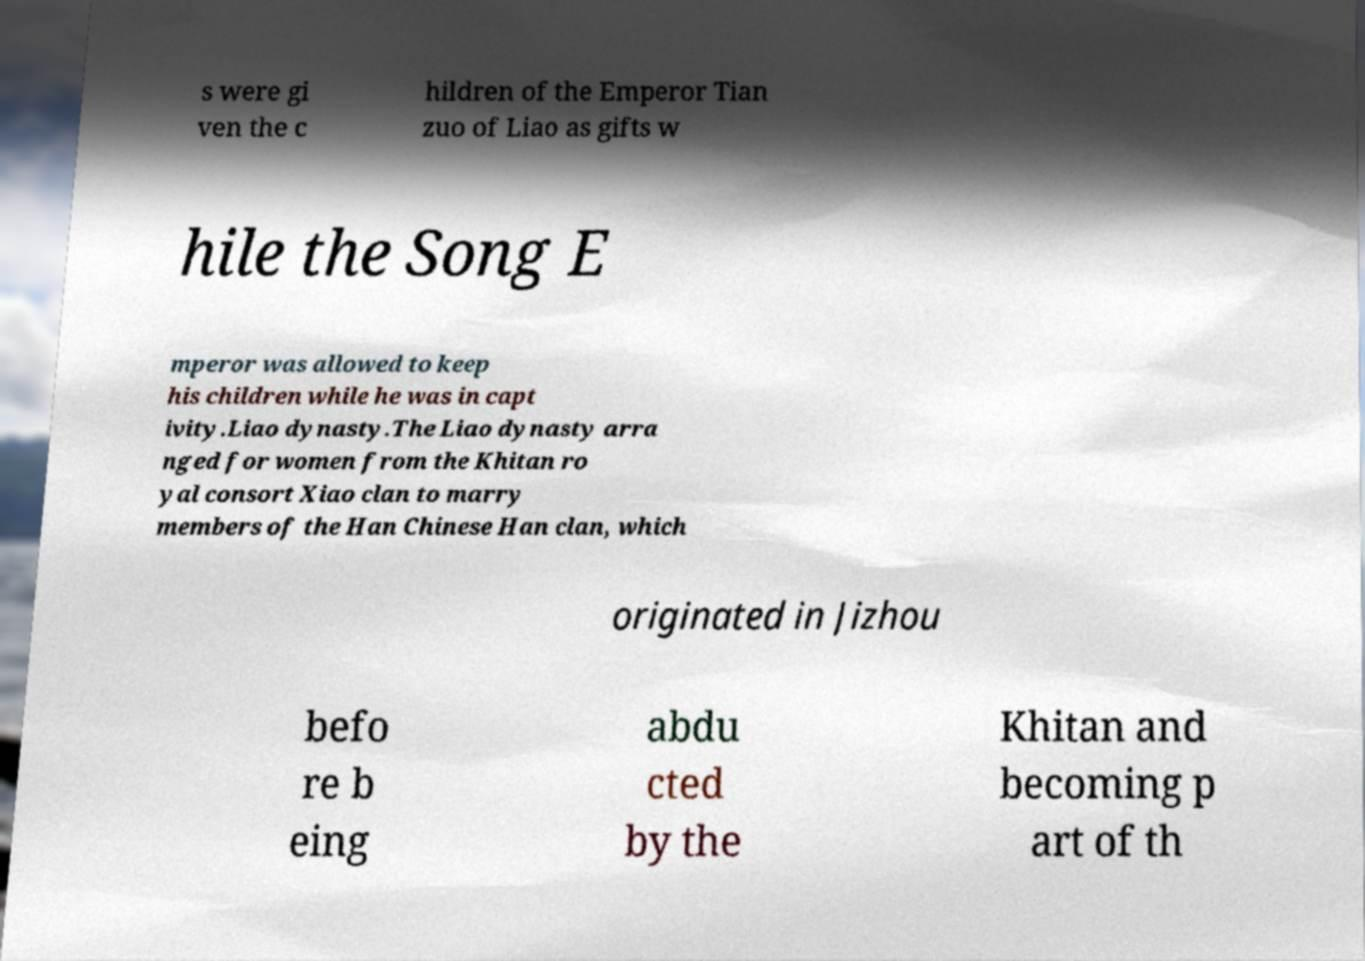Could you extract and type out the text from this image? s were gi ven the c hildren of the Emperor Tian zuo of Liao as gifts w hile the Song E mperor was allowed to keep his children while he was in capt ivity.Liao dynasty.The Liao dynasty arra nged for women from the Khitan ro yal consort Xiao clan to marry members of the Han Chinese Han clan, which originated in Jizhou befo re b eing abdu cted by the Khitan and becoming p art of th 